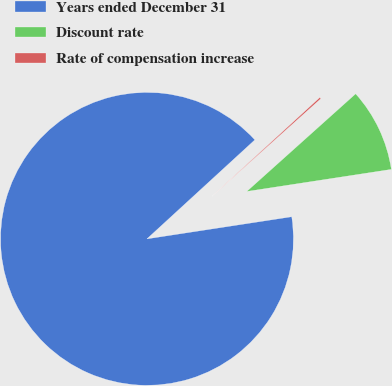Convert chart to OTSL. <chart><loc_0><loc_0><loc_500><loc_500><pie_chart><fcel>Years ended December 31<fcel>Discount rate<fcel>Rate of compensation increase<nl><fcel>90.6%<fcel>9.22%<fcel>0.18%<nl></chart> 